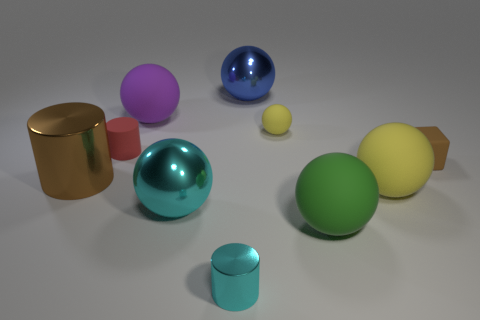Subtract all big purple balls. How many balls are left? 5 Subtract all blocks. How many objects are left? 9 Subtract 3 balls. How many balls are left? 3 Add 3 large green matte spheres. How many large green matte spheres exist? 4 Subtract all cyan cylinders. How many cylinders are left? 2 Subtract 0 gray blocks. How many objects are left? 10 Subtract all red cubes. Subtract all brown cylinders. How many cubes are left? 1 Subtract all red spheres. How many cyan cylinders are left? 1 Subtract all tiny gray cylinders. Subtract all large blue objects. How many objects are left? 9 Add 2 big purple spheres. How many big purple spheres are left? 3 